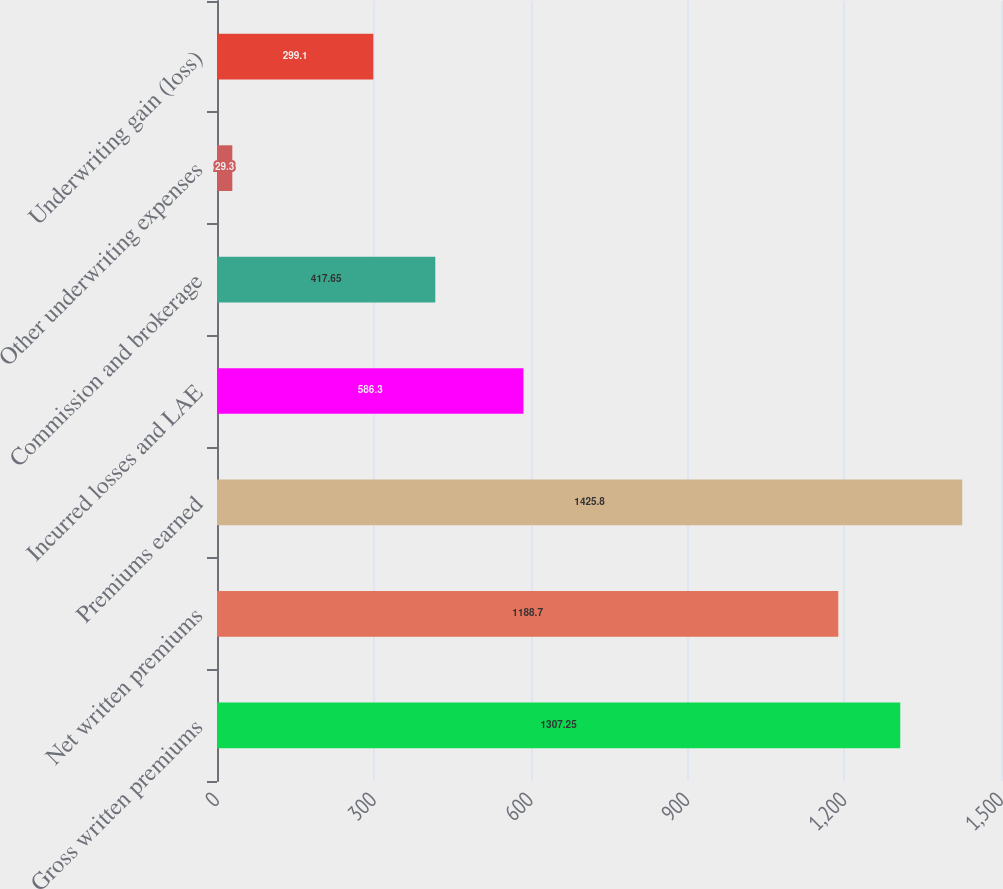Convert chart. <chart><loc_0><loc_0><loc_500><loc_500><bar_chart><fcel>Gross written premiums<fcel>Net written premiums<fcel>Premiums earned<fcel>Incurred losses and LAE<fcel>Commission and brokerage<fcel>Other underwriting expenses<fcel>Underwriting gain (loss)<nl><fcel>1307.25<fcel>1188.7<fcel>1425.8<fcel>586.3<fcel>417.65<fcel>29.3<fcel>299.1<nl></chart> 